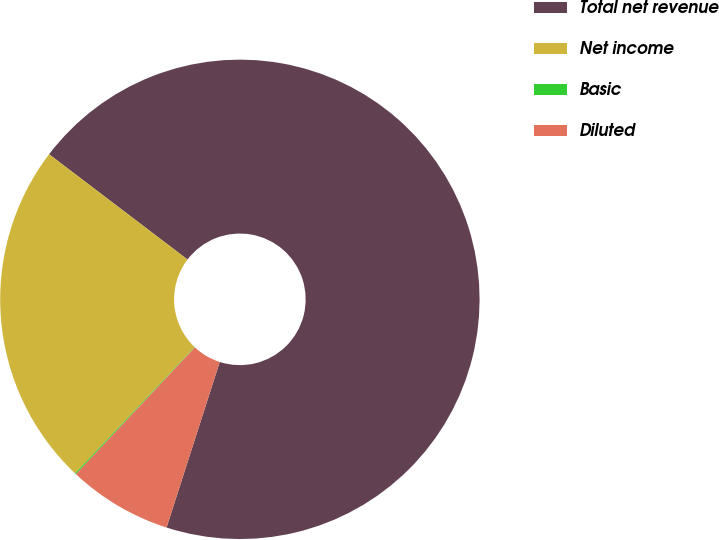Convert chart to OTSL. <chart><loc_0><loc_0><loc_500><loc_500><pie_chart><fcel>Total net revenue<fcel>Net income<fcel>Basic<fcel>Diluted<nl><fcel>69.6%<fcel>23.28%<fcel>0.08%<fcel>7.04%<nl></chart> 